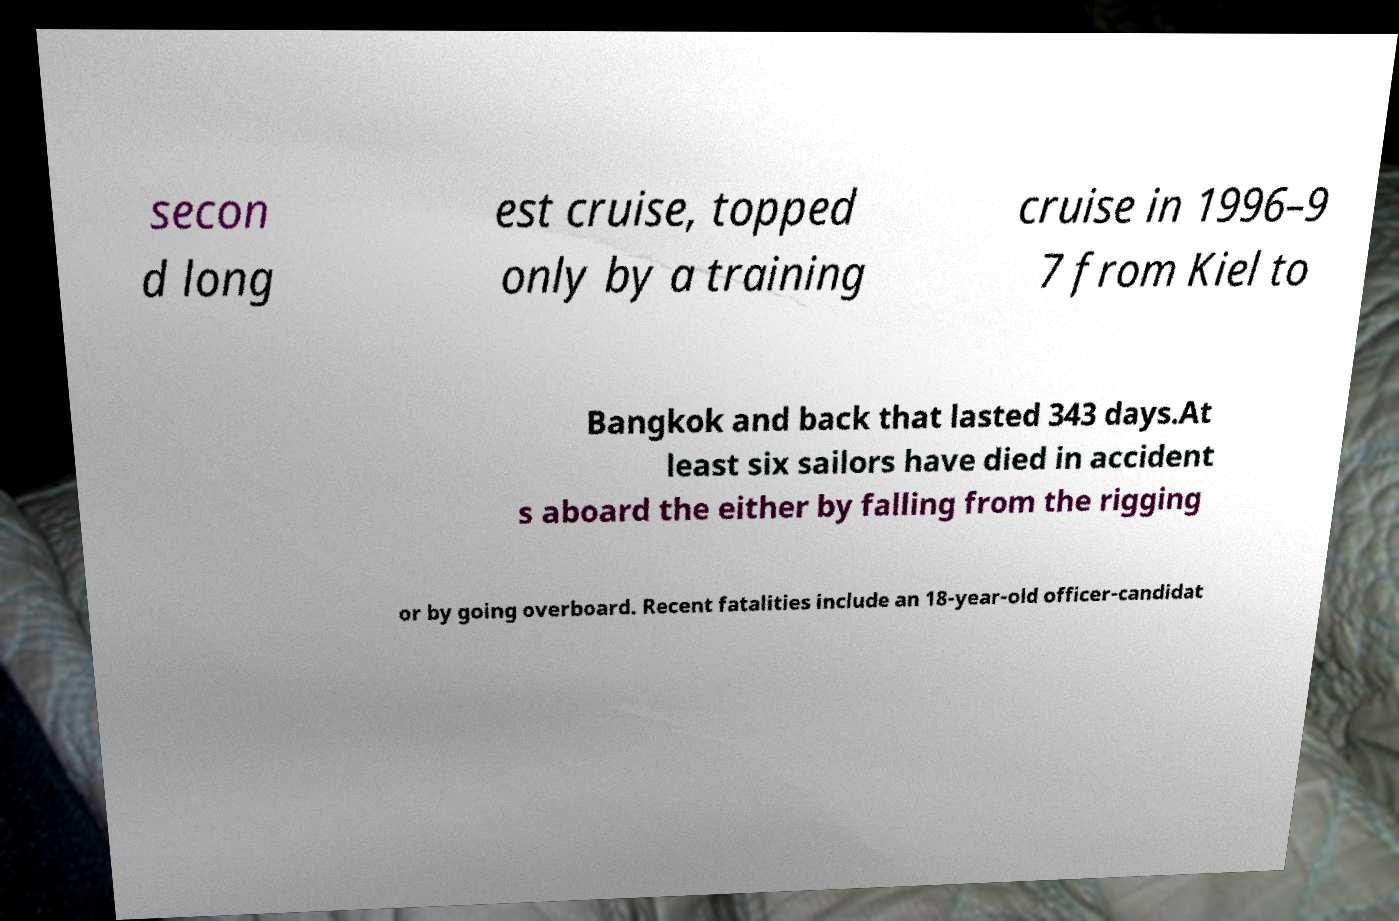Please identify and transcribe the text found in this image. secon d long est cruise, topped only by a training cruise in 1996–9 7 from Kiel to Bangkok and back that lasted 343 days.At least six sailors have died in accident s aboard the either by falling from the rigging or by going overboard. Recent fatalities include an 18-year-old officer-candidat 